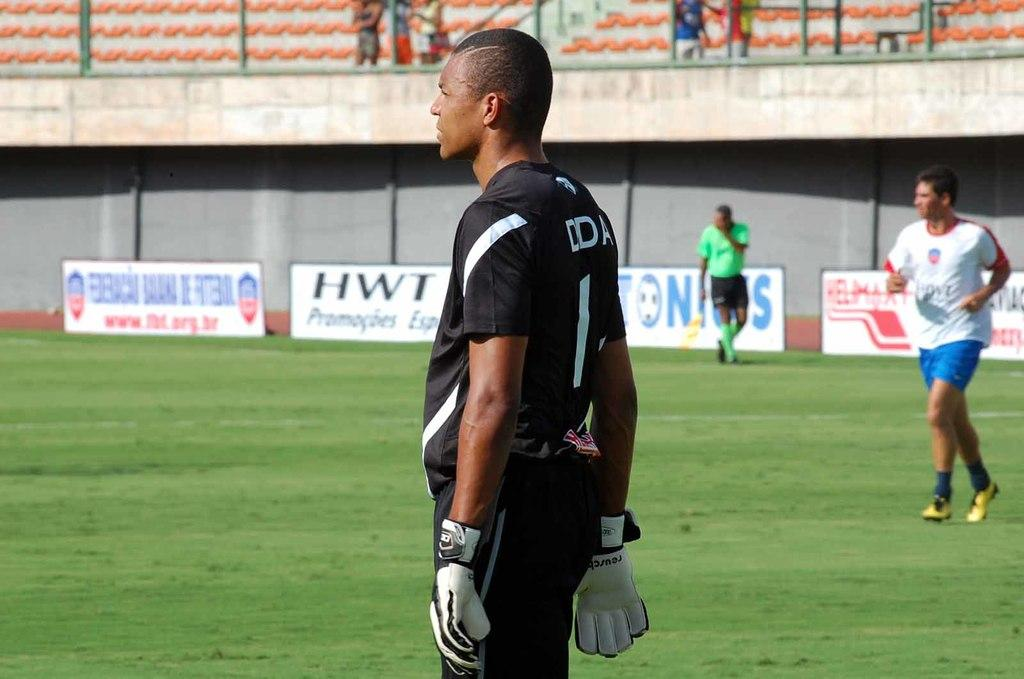Provide a one-sentence caption for the provided image. HWT is one of the companies advertising on the sidelines. 